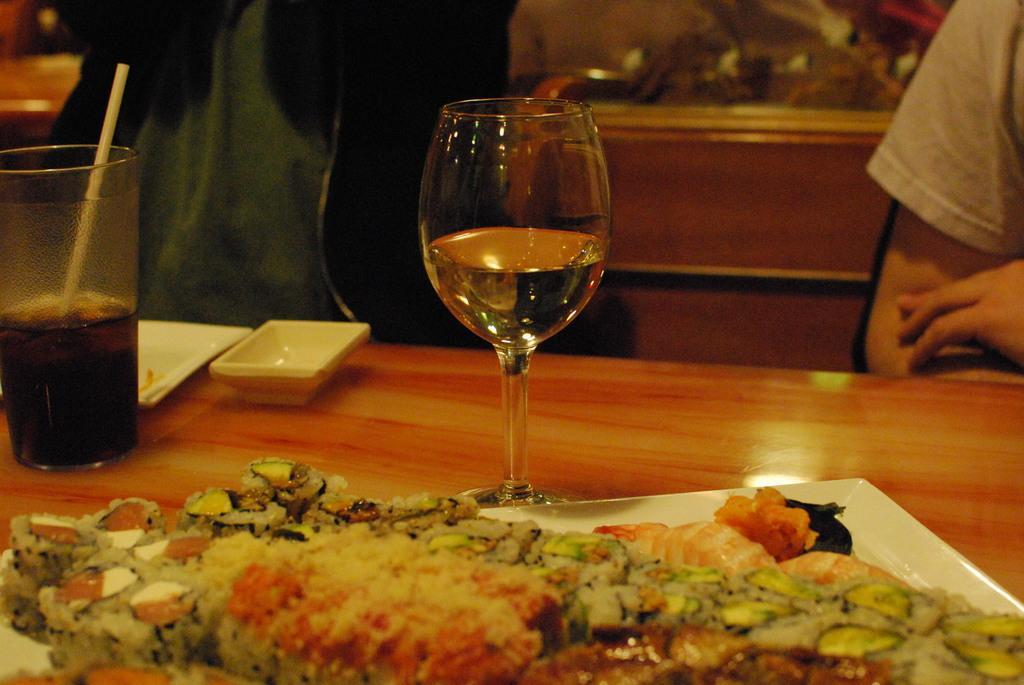In one or two sentences, can you explain what this image depicts? In this picture, we see a table on which a glass containing liquid, plate, glass containing cool drink and a plate containing food are placed. Behind that, we see two people and this picture might be clicked in the restaurant. 